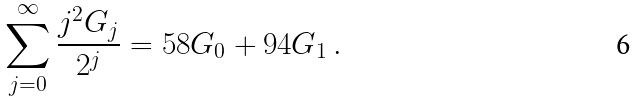<formula> <loc_0><loc_0><loc_500><loc_500>\sum _ { j = 0 } ^ { \infty } { \frac { j ^ { 2 } G _ { j } } { 2 ^ { j } } } = 5 8 G _ { 0 } + 9 4 G _ { 1 } \, .</formula> 